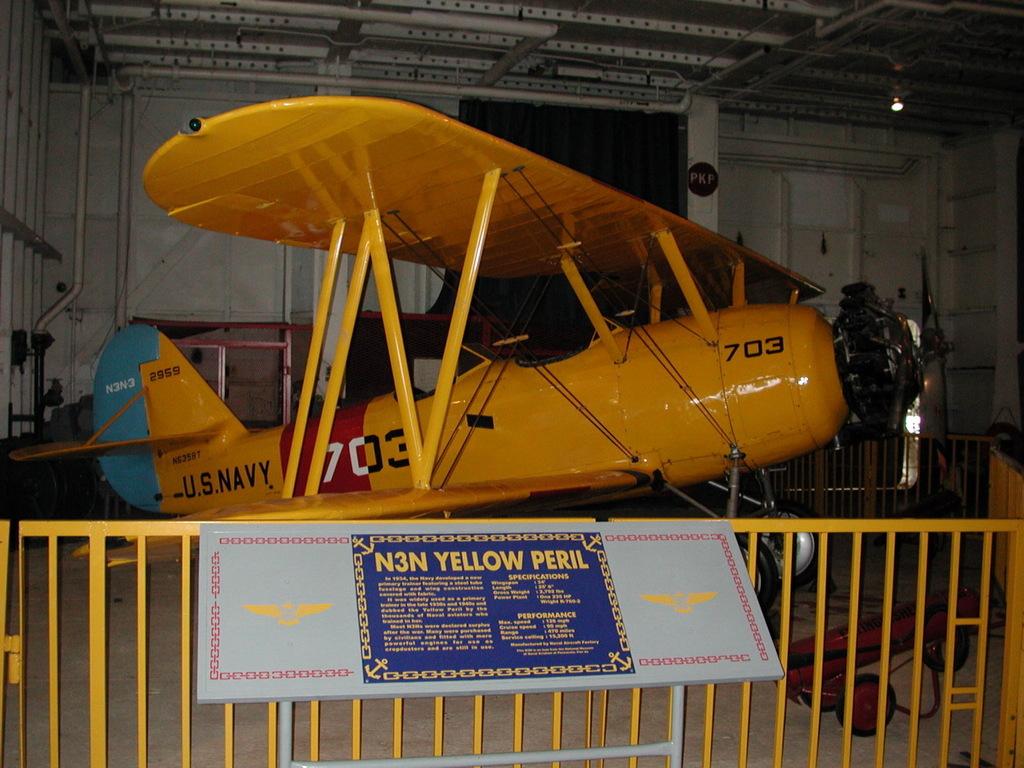What armed service is the plane for?
Make the answer very short. Navy. What is the name of the plane?
Offer a terse response. N3n yellow peril. 